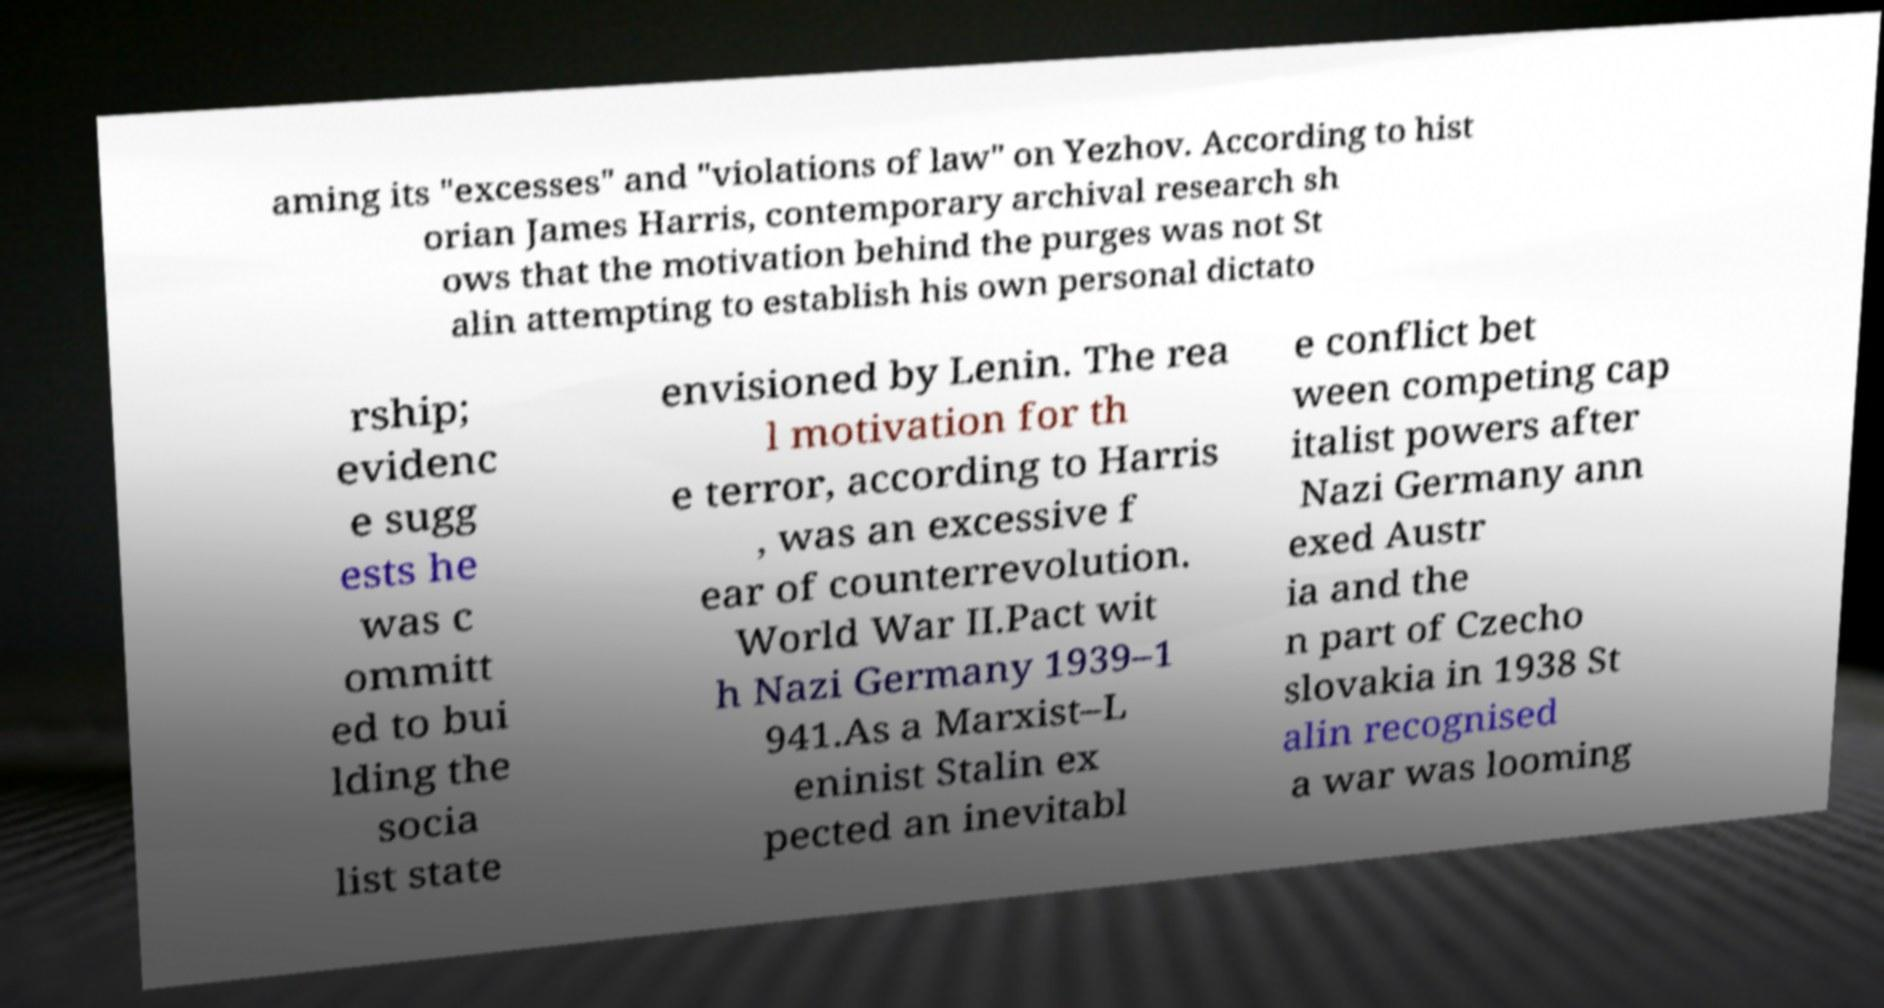There's text embedded in this image that I need extracted. Can you transcribe it verbatim? aming its "excesses" and "violations of law" on Yezhov. According to hist orian James Harris, contemporary archival research sh ows that the motivation behind the purges was not St alin attempting to establish his own personal dictato rship; evidenc e sugg ests he was c ommitt ed to bui lding the socia list state envisioned by Lenin. The rea l motivation for th e terror, according to Harris , was an excessive f ear of counterrevolution. World War II.Pact wit h Nazi Germany 1939–1 941.As a Marxist–L eninist Stalin ex pected an inevitabl e conflict bet ween competing cap italist powers after Nazi Germany ann exed Austr ia and the n part of Czecho slovakia in 1938 St alin recognised a war was looming 